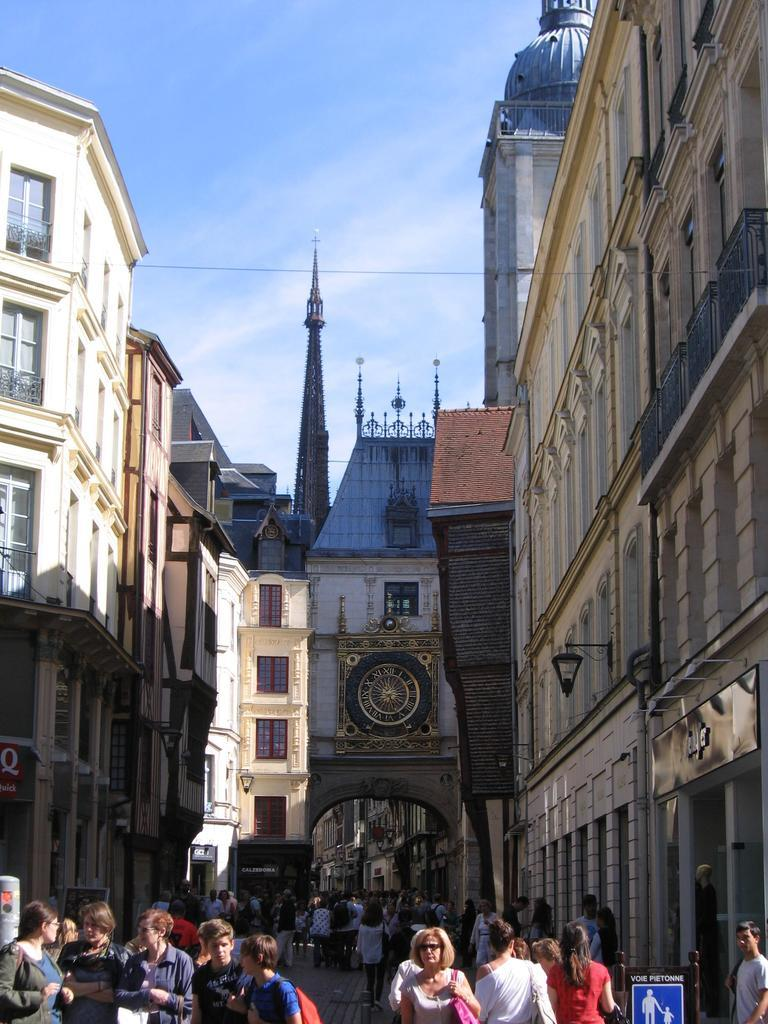What are the people in the image doing? There are persons walking in the street in the image. What can be seen on the left side of the picture? There are buildings on the left side of the picture. What can be seen on the right side of the picture? There are buildings on the right side of the picture. What is the color of the sky in the image? The sky is blue at the top of the picture. How much money is being exchanged between the people in the image? There is no indication of money exchange in the image; people are simply walking in the street. 